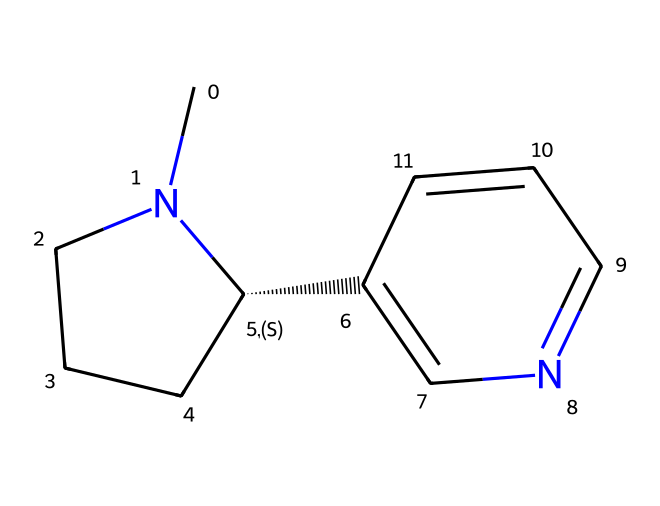What is the molecular formula of nicotine? Analyzing the SMILES representation, we identify each element present. The carbon (C) atoms total to 10, hydrogen (H) atoms to 14, and nitrogen (N) atoms to 2. Therefore, the molecular formula is C10H14N2.
Answer: C10H14N2 How many nitrogen atoms are present in the nicotine structure? By inspecting the SMILES structure, we see that there are two nitrogen (N) atoms indicated in the molecular formula.
Answer: 2 What type of functional groups are present in nicotine? In the structure, the presence of nitrogen atoms suggests it bears an amine functional group, which is characteristic of many alkaloids. There are no hydroxyl or carboxyl groups visible.
Answer: amine Does nicotine contain any rings in its structure? The SMILES indicates the presence of two separate rings based on the notation '1' and '2', which signifies interconnected cyclic structures.
Answer: yes How many total carbon atoms are in nicotine? Counting the carbon (C) indicators in the SMILES structure, we tally a total of 10 carbon atoms.
Answer: 10 What type of chemical is nicotine classified as? Given its nitrogen content and the overall structure, it is classified as an alkaloid, which are naturally occurring compounds primarily derived from plant sources.
Answer: alkaloid Why is nicotine considered psychoactive? The nitrogen atoms allow nicotine to interact with specific receptors in the brain, leading to altered states of perception. This mechanism is typical for many alkaloids.
Answer: psychoactive 